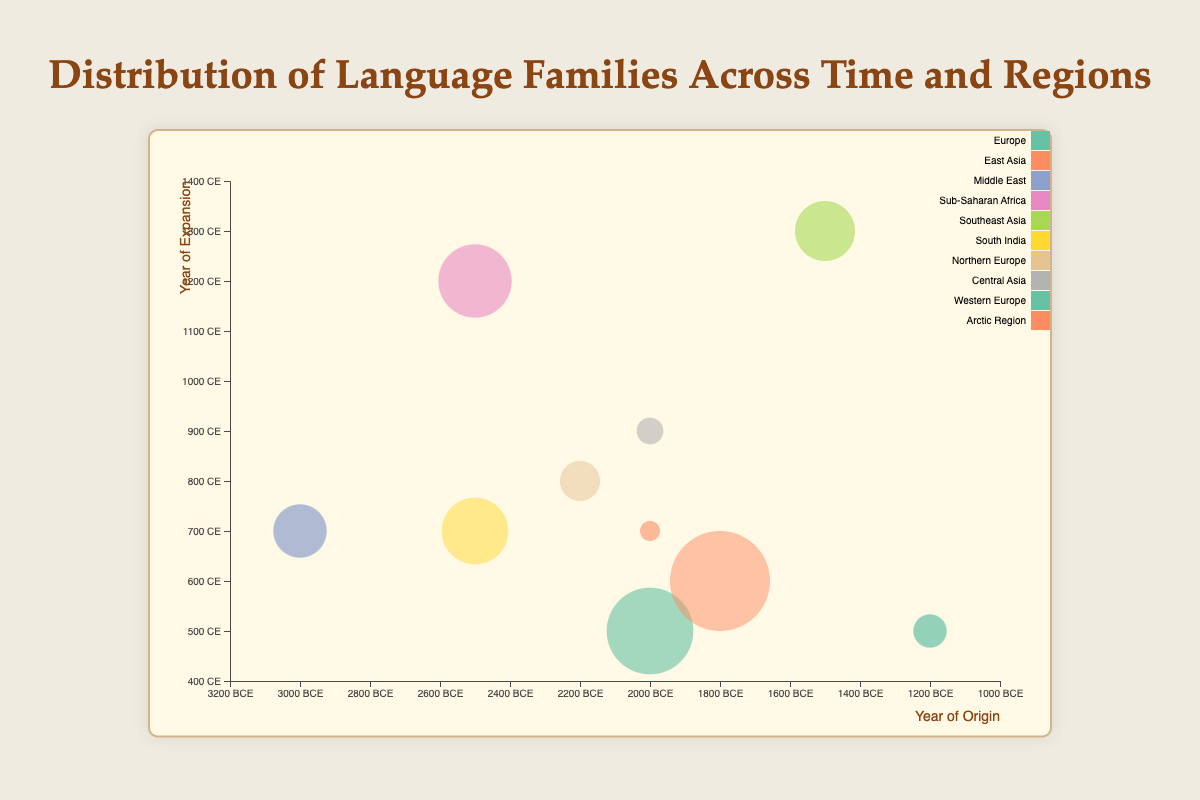What is the title of the chart? The title is displayed prominently at the top of the chart page.
Answer: Distribution of Language Families Across Time and Regions Which language family bubble has the largest size on the chart? Compare the bubble sizes across all the data points; the language family "Sino-Tibetan" has the largest bubble size of 85.
Answer: Sino-Tibetan In which year of origin and region is the Indo-European language family located? The X-axis represents the year of origin, and the region is displayed as part of the tooltip when hovering over the bubble corresponding to "Indo-European." The data shows "Indo-European" has an origin of -2000 and is located in Europe.
Answer: -2000, Europe Which language family's bubble is located furthest to the right on the chart? The X-axis measures the year of origin, with increasing years to the right of the chart. The bubble for "Afro-Asiatic" is located furthest to the right with an X-axis value of -3000.
Answer: Afro-Asiatic Compare the transparency of bubbles between Afro-Asiatic and Celtic language families. Which one is more transparent? The transparency value for each bubble is provided in the data. "Afro-Asiatic" has a transparency of 0.7, while "Celtic" has a transparency of 0.7; both are equally transparent.
Answer: Both are equally transparent What is the average bubble size for all the language families displayed on the chart? Sum all the bubble sizes and divide by the number of data points: (75+85+50+65+55+60+40+30+35+25)/10 = 52
Answer: 52 Which two language families experienced their main expansion in the same year? The Y-axis represents the year of expansion, and comparing data points for equality, both "Afro-Asiatic" and "Eskimo-Aleut" have an expansion year of 700.
Answer: Afro-Asiatic and Eskimo-Aleut What is the difference in the year of expansion between Indo-European and Dravidian language families? The Y-Axis represents years of expansion. Indo-European has a Y-Axis value of 500, and Dravidian has a Y-Axis value of 700. The difference is 700 - 500 = 200.
Answer: 200 Which region has the most language families originated from it according to the chart? Counting the occurrences of each region, "Europe" appears twice (Indo-European and Celtic), while other regions only appear once.
Answer: Europe How does the year of origin of the Eskimo-Aleut language family compare to the year of origin of the Uralic language family? The X-axis represents the year of origin. Eskimo-Aleut has an origin year of -2000, and Uralic has an origin year of -2200. -2200 is earlier than -2000.
Answer: Uralic has an earlier year of origin 